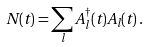Convert formula to latex. <formula><loc_0><loc_0><loc_500><loc_500>N ( t ) = \sum _ { l } A ^ { \dagger } _ { l } ( t ) A _ { l } ( t ) \, .</formula> 